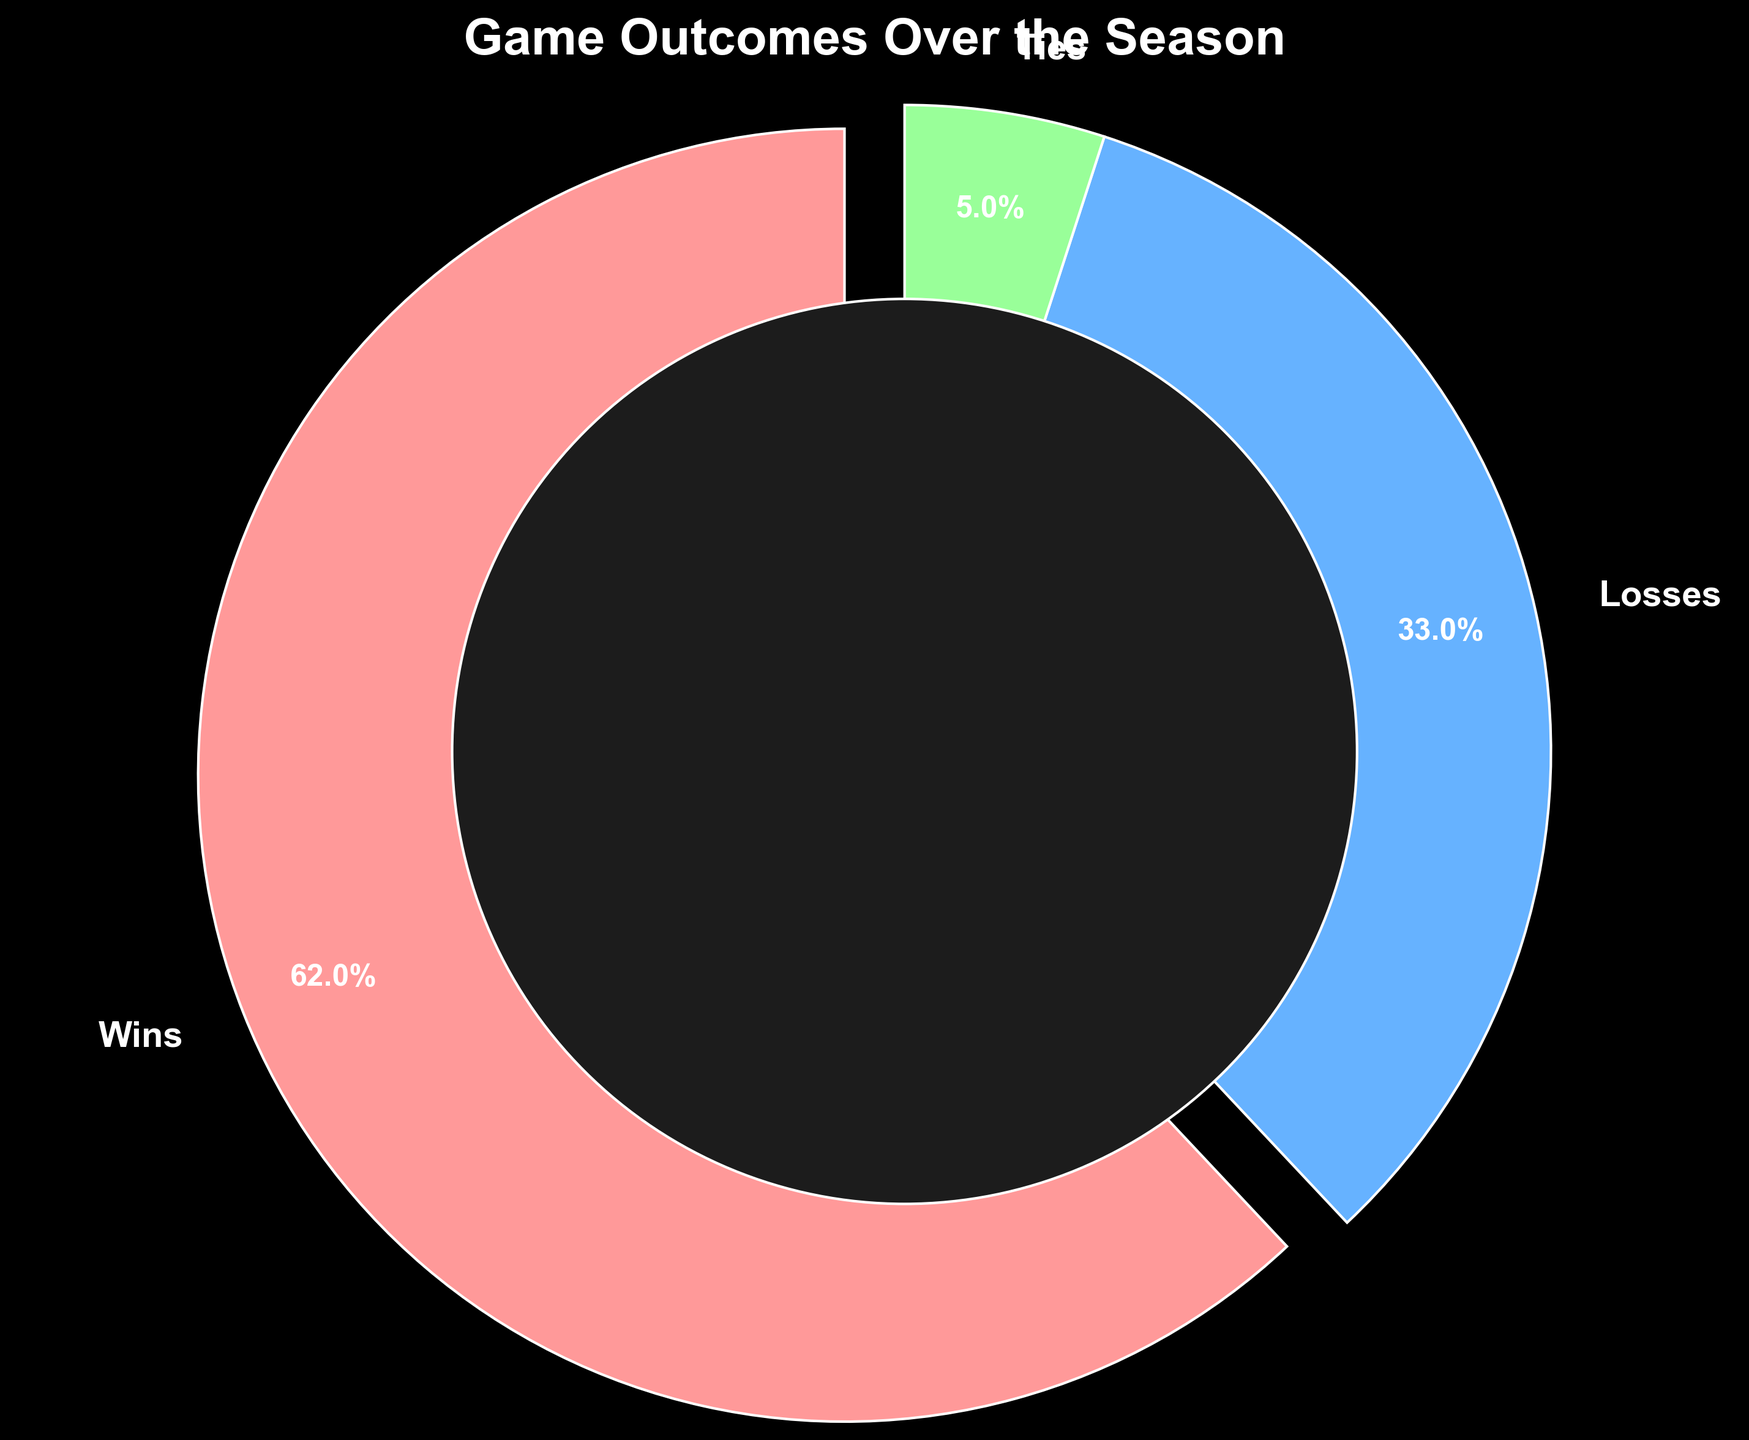What proportion of the games resulted in losses? Referring to the pie chart, the segment labeled "Losses" shows 33%.
Answer: 33% What is the least common game outcome? The segment labeled "Ties" shows the smallest percentage, which is 5%.
Answer: Ties How much larger is the percentage of wins compared to losses? The wins segment shows 62% and the losses segment shows 33%. The difference is 62% - 33% = 29%.
Answer: 29% If the total number of games is 20, how many games ended in a tie? Ties account for 5% of the total. 5% of 20 games is 0.05 * 20 = 1 game.
Answer: 1 game How does the percentage of losses compare to the percentage of ties? The losses segment shows 33%, while the ties segment shows 5%. Losses are 33% - 5% = 28% more common than ties.
Answer: 28% What colors represent wins, losses, and ties in the chart? Wins are represented by a red slice, losses by a blue slice, and ties by a green slice.
Answer: Wins: red, Losses: blue, Ties: green Which game outcome is represented by the largest wedge in the pie chart? The largest wedge, indicated by its size, is labeled "Wins," showing 62%.
Answer: Wins What is the combined percentage of losses and ties? The losses are 33% and the ties are 5%. Combined, they add up to 33% + 5% = 38%.
Answer: 38% What feature draws attention to the wins slice in the pie chart? The wins slice is slightly separated from the rest (exploded) and has a bold label, making it stand out.
Answer: Separation and bold label In a 30-game season, how many were wins, losses, and ties? Wins: 62% of 30 is 0.62 * 30 = 18.6, rounded to 19 games. Losses: 33% of 30 is 0.33 * 30 = 9.9, rounded to 10 games. Ties: 5% of 30 is 0.05 * 30 = 1.5, rounded to 1 game.
Answer: Wins: 19, Losses: 10, Ties: 1 